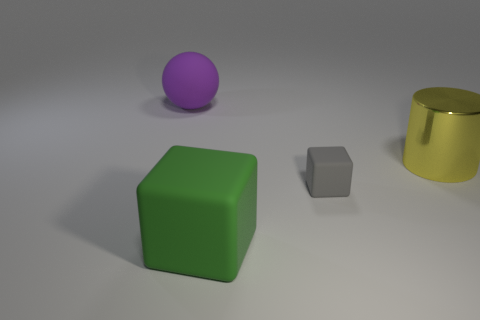How do the sizes of the objects compare with each other? In the image, the green cube is the largest object, followed by the yellow cylinder, which is slightly shorter but also has a wider diameter. The purple sphere is smaller than both the cube and the cylinder. The smallest object is the gray cube, which appears to be a fraction of the size of the green cube. 